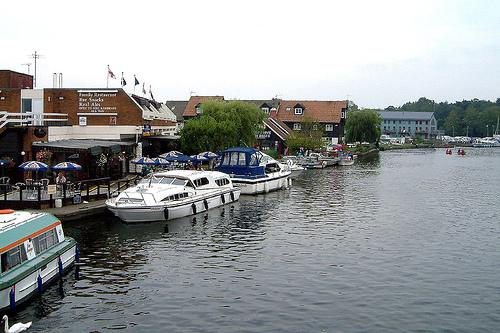Question: how many boats can be seen?
Choices:
A. Two.
B. Ten.
C. Six.
D. Three.
Answer with the letter. Answer: C Question: where are the boats?
Choices:
A. Marina.
B. Ocean.
C. Under a bridge.
D. In a canal.
Answer with the letter. Answer: A Question: what are the boats in?
Choices:
A. Water.
B. Garages.
C. Trailers.
D. Harbors.
Answer with the letter. Answer: A 